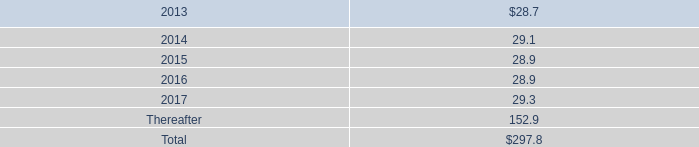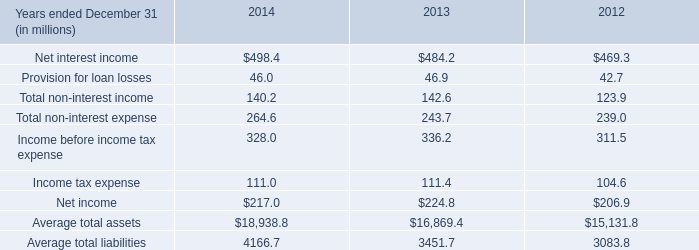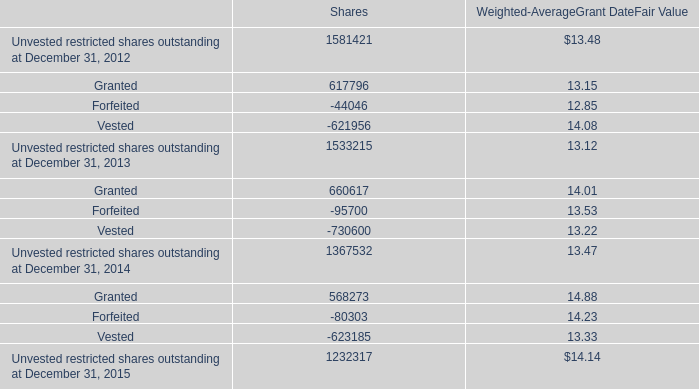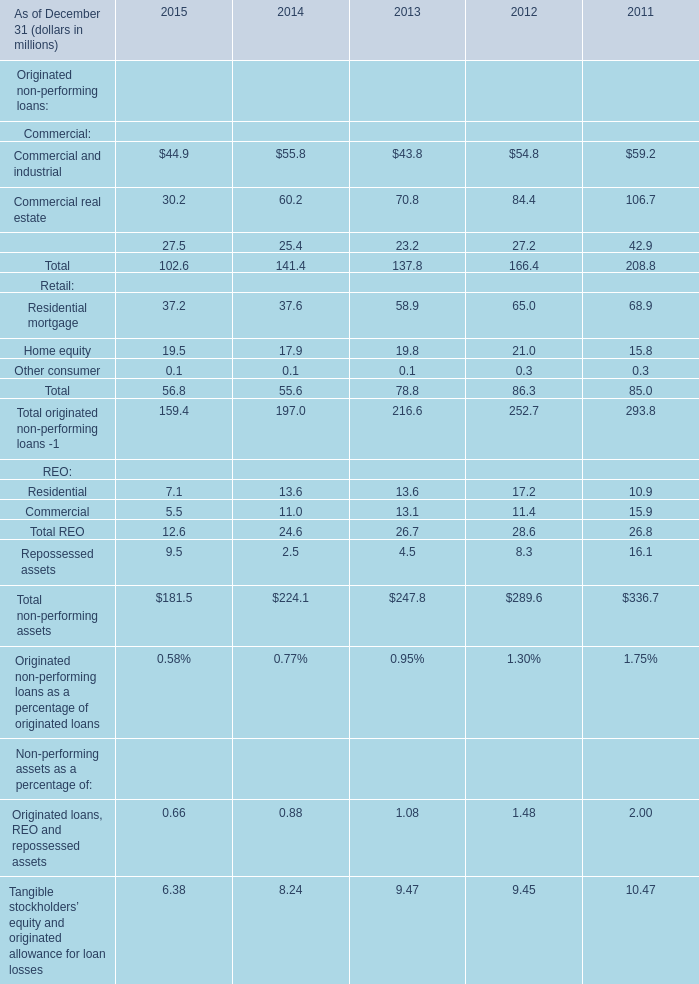Which commercial has the second largest number in 2015? 
Answer: Commercial real estate. 